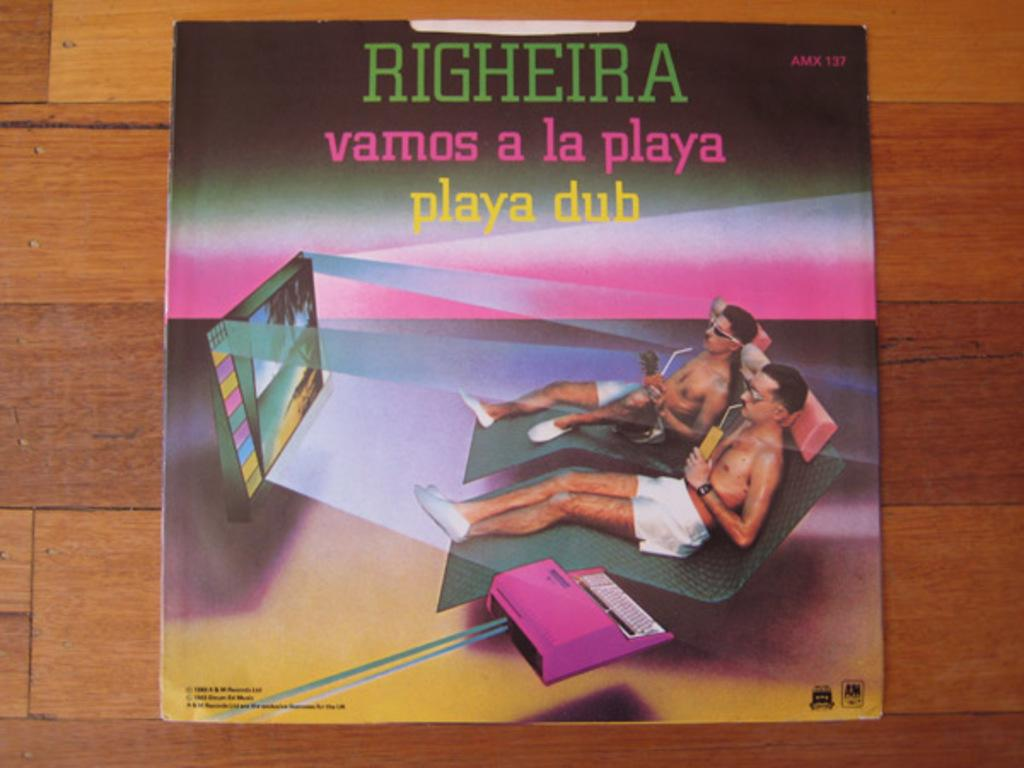<image>
Provide a brief description of the given image. The cover of a compact disc titled Righeira contains the A&M Records logo. 